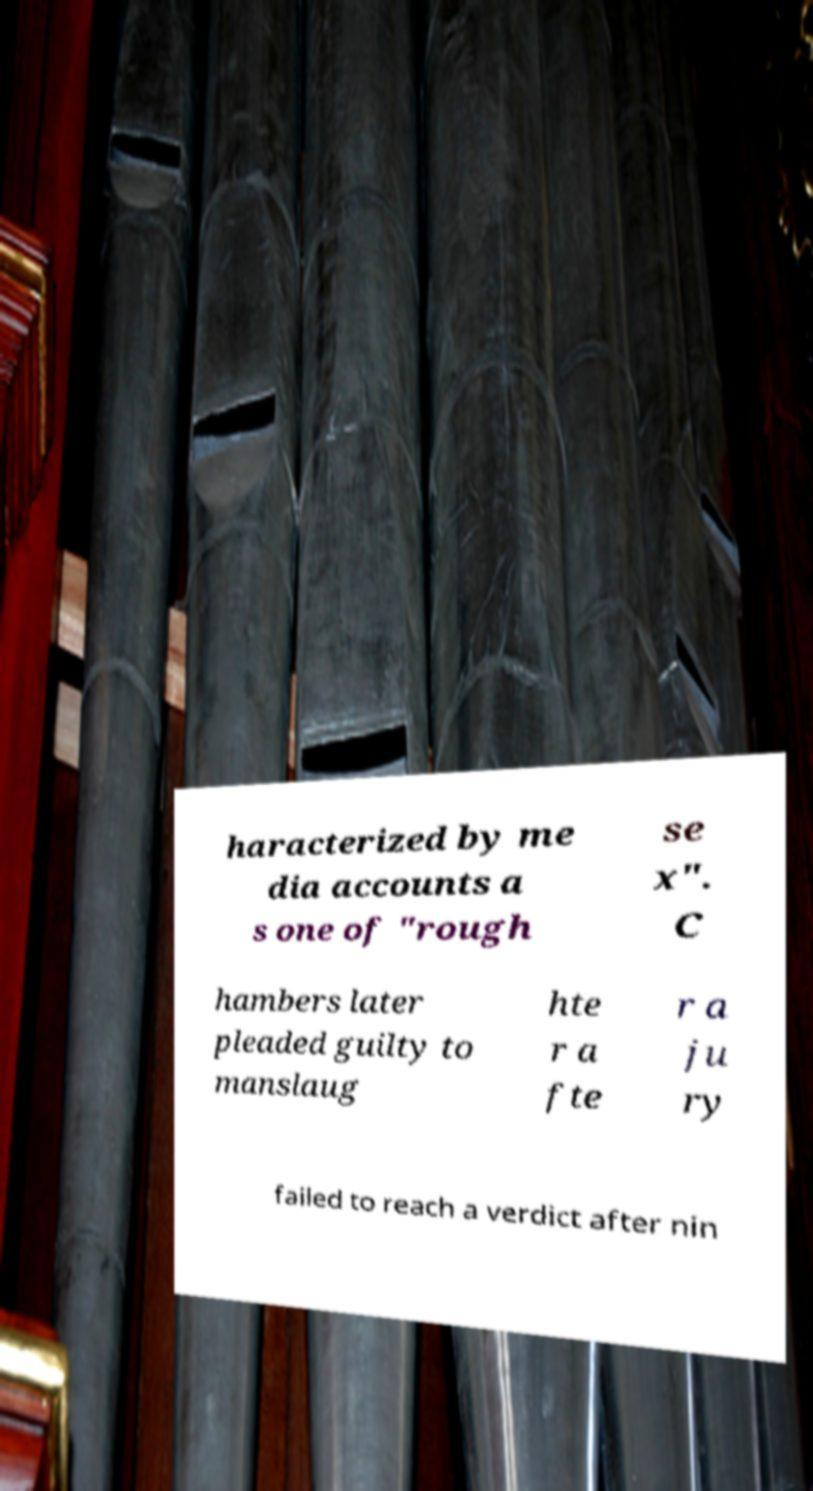I need the written content from this picture converted into text. Can you do that? haracterized by me dia accounts a s one of "rough se x". C hambers later pleaded guilty to manslaug hte r a fte r a ju ry failed to reach a verdict after nin 